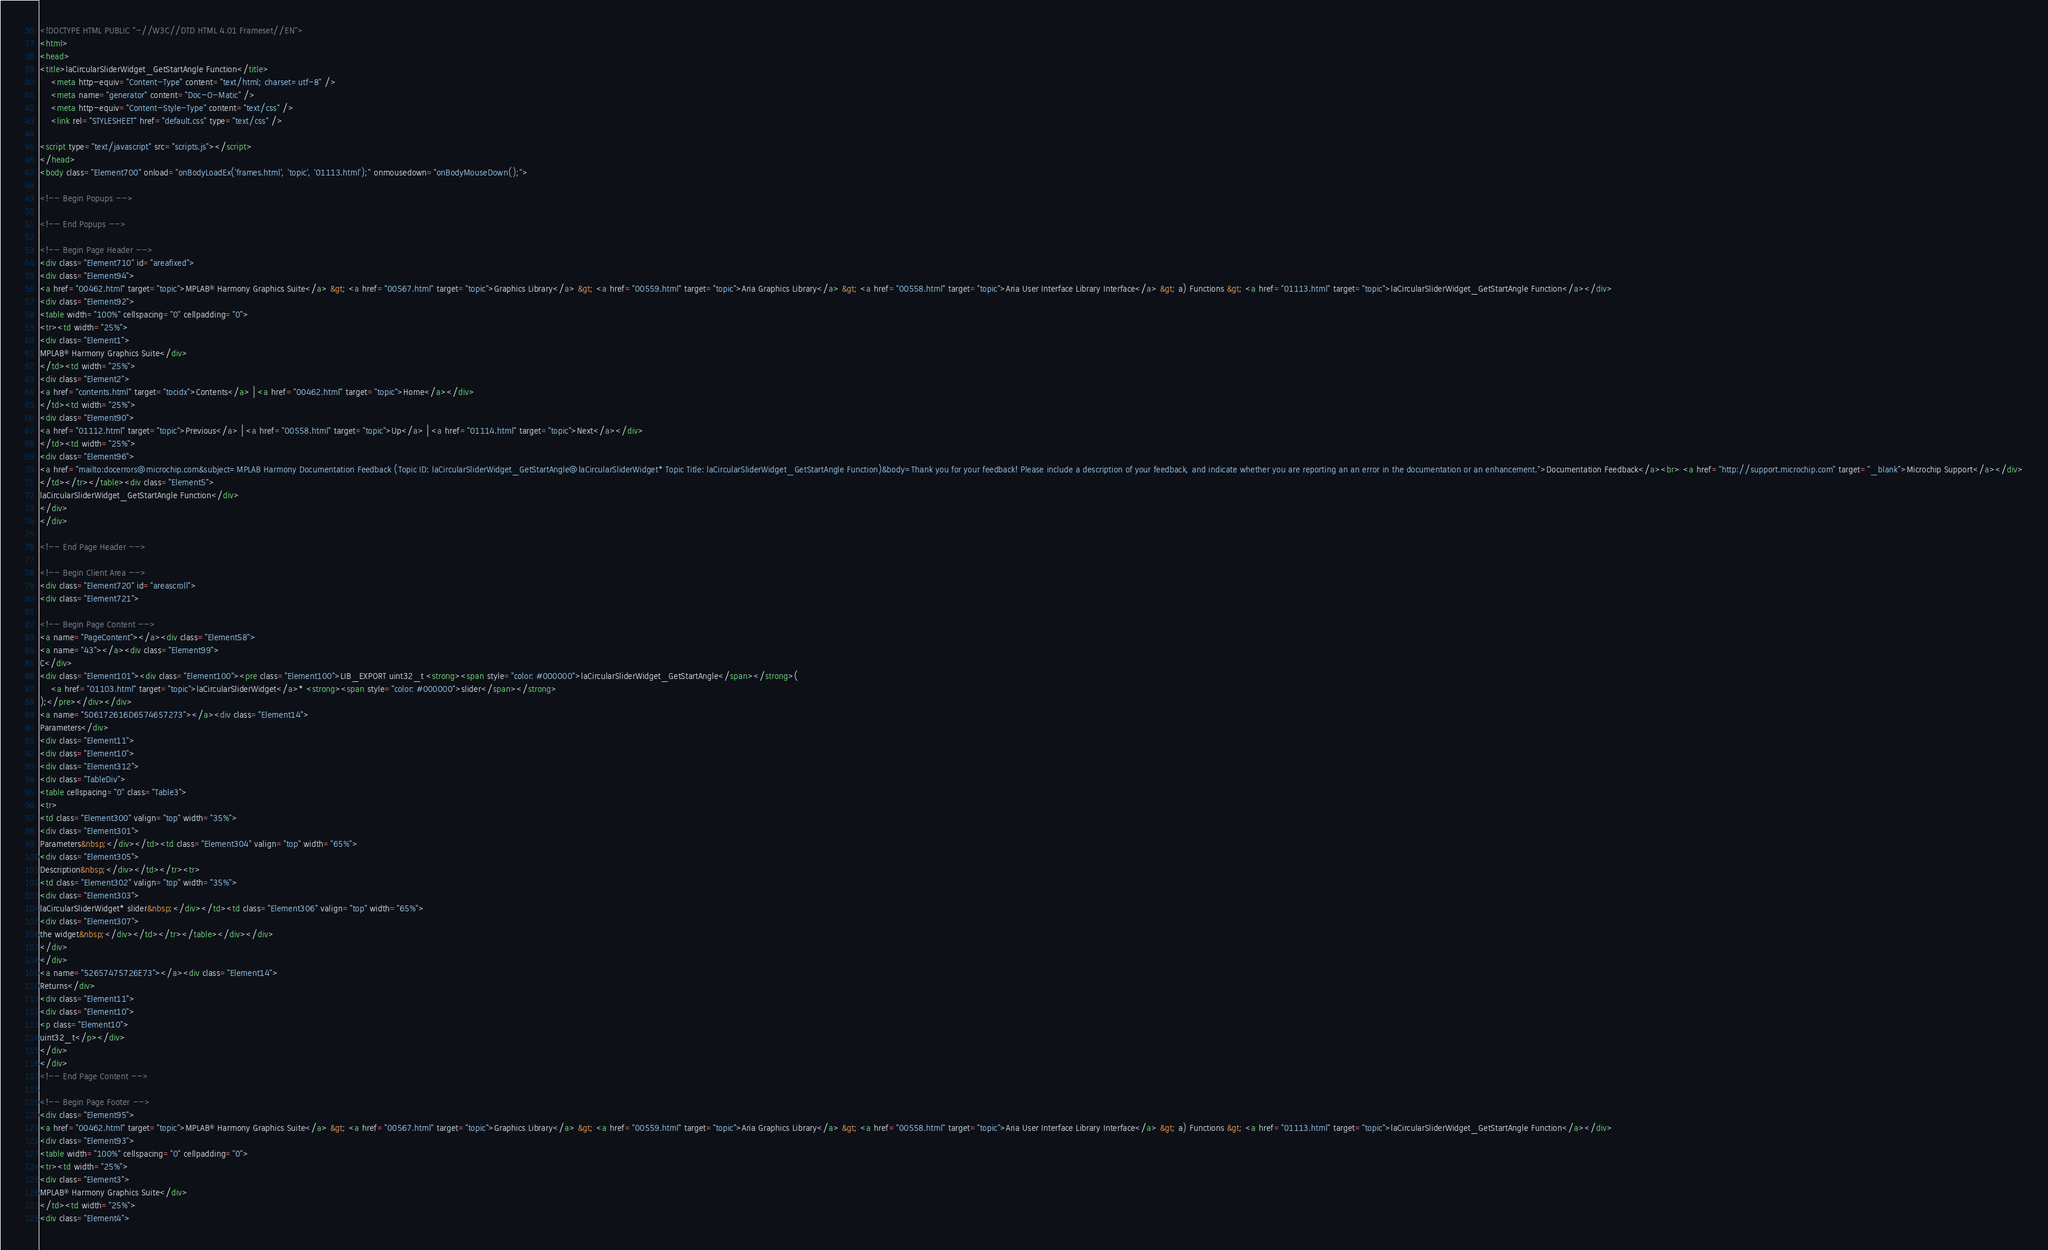<code> <loc_0><loc_0><loc_500><loc_500><_HTML_><!DOCTYPE HTML PUBLIC "-//W3C//DTD HTML 4.01 Frameset//EN">
<html>
<head>
<title>laCircularSliderWidget_GetStartAngle Function</title>
    <meta http-equiv="Content-Type" content="text/html; charset=utf-8" />
    <meta name="generator" content="Doc-O-Matic" />
    <meta http-equiv="Content-Style-Type" content="text/css" />
    <link rel="STYLESHEET" href="default.css" type="text/css" />

<script type="text/javascript" src="scripts.js"></script>
</head>
<body class="Element700" onload="onBodyLoadEx('frames.html', 'topic', '01113.html');" onmousedown="onBodyMouseDown();">

<!-- Begin Popups -->

<!-- End Popups -->

<!-- Begin Page Header -->
<div class="Element710" id="areafixed">
<div class="Element94">
<a href="00462.html" target="topic">MPLAB® Harmony Graphics Suite</a> &gt; <a href="00567.html" target="topic">Graphics Library</a> &gt; <a href="00559.html" target="topic">Aria Graphics Library</a> &gt; <a href="00558.html" target="topic">Aria User Interface Library Interface</a> &gt; a) Functions &gt; <a href="01113.html" target="topic">laCircularSliderWidget_GetStartAngle Function</a></div>
<div class="Element92">
<table width="100%" cellspacing="0" cellpadding="0">
<tr><td width="25%">
<div class="Element1">
MPLAB® Harmony Graphics Suite</div>
</td><td width="25%">
<div class="Element2">
<a href="contents.html" target="tocidx">Contents</a> | <a href="00462.html" target="topic">Home</a></div>
</td><td width="25%">
<div class="Element90">
<a href="01112.html" target="topic">Previous</a> | <a href="00558.html" target="topic">Up</a> | <a href="01114.html" target="topic">Next</a></div>
</td><td width="25%">
<div class="Element96">
<a href="mailto:docerrors@microchip.com&subject=MPLAB Harmony Documentation Feedback (Topic ID: laCircularSliderWidget_GetStartAngle@laCircularSliderWidget* Topic Title: laCircularSliderWidget_GetStartAngle Function)&body=Thank you for your feedback! Please include a description of your feedback, and indicate whether you are reporting an an error in the documentation or an enhancement.">Documentation Feedback</a><br> <a href="http://support.microchip.com" target="_blank">Microchip Support</a></div>
</td></tr></table><div class="Element5">
laCircularSliderWidget_GetStartAngle Function</div>
</div>
</div>

<!-- End Page Header -->

<!-- Begin Client Area -->
<div class="Element720" id="areascroll">
<div class="Element721">

<!-- Begin Page Content -->
<a name="PageContent"></a><div class="Element58">
<a name="43"></a><div class="Element99">
C</div>
<div class="Element101"><div class="Element100"><pre class="Element100">LIB_EXPORT uint32_t <strong><span style="color: #000000">laCircularSliderWidget_GetStartAngle</span></strong>(
    <a href="01103.html" target="topic">laCircularSliderWidget</a>* <strong><span style="color: #000000">slider</span></strong>
);</pre></div></div>
<a name="506172616D6574657273"></a><div class="Element14">
Parameters</div>
<div class="Element11">
<div class="Element10">
<div class="Element312">
<div class="TableDiv">
<table cellspacing="0" class="Table3">
<tr>
<td class="Element300" valign="top" width="35%">
<div class="Element301">
Parameters&nbsp;</div></td><td class="Element304" valign="top" width="65%">
<div class="Element305">
Description&nbsp;</div></td></tr><tr>
<td class="Element302" valign="top" width="35%">
<div class="Element303">
laCircularSliderWidget* slider&nbsp;</div></td><td class="Element306" valign="top" width="65%">
<div class="Element307">
the widget&nbsp;</div></td></tr></table></div></div>
</div>
</div>
<a name="52657475726E73"></a><div class="Element14">
Returns</div>
<div class="Element11">
<div class="Element10">
<p class="Element10">
uint32_t</p></div>
</div>
</div>
<!-- End Page Content -->

<!-- Begin Page Footer -->
<div class="Element95">
<a href="00462.html" target="topic">MPLAB® Harmony Graphics Suite</a> &gt; <a href="00567.html" target="topic">Graphics Library</a> &gt; <a href="00559.html" target="topic">Aria Graphics Library</a> &gt; <a href="00558.html" target="topic">Aria User Interface Library Interface</a> &gt; a) Functions &gt; <a href="01113.html" target="topic">laCircularSliderWidget_GetStartAngle Function</a></div>
<div class="Element93">
<table width="100%" cellspacing="0" cellpadding="0">
<tr><td width="25%">
<div class="Element3">
MPLAB® Harmony Graphics Suite</div>
</td><td width="25%">
<div class="Element4"></code> 